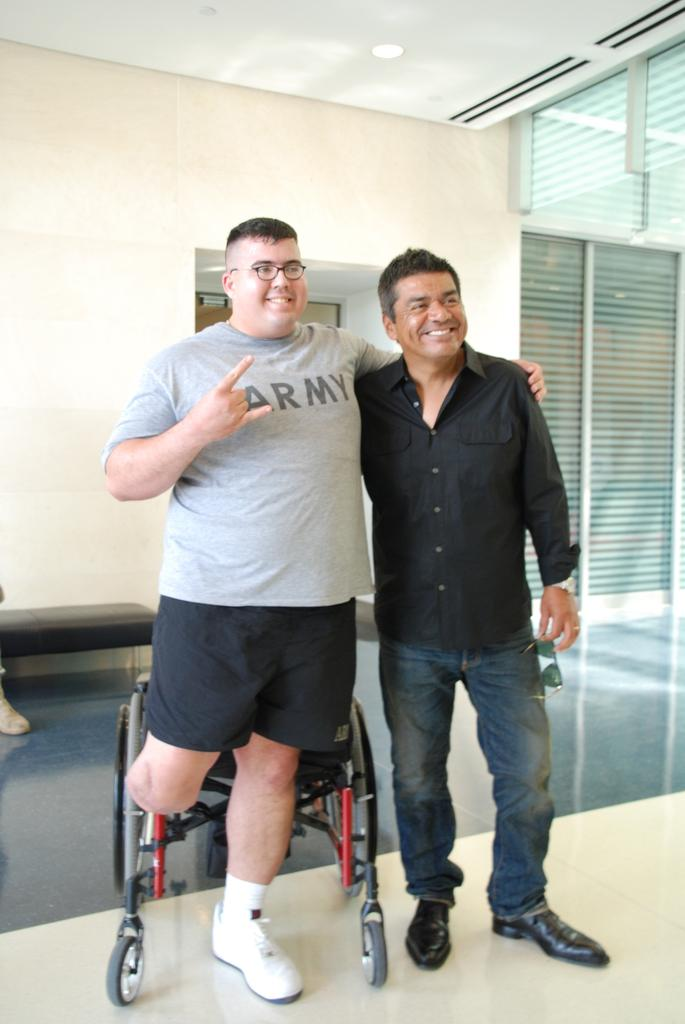How many people are present in the image? There are two persons standing in the image. What is located behind one of the persons? There is a wheelchair behind one of the persons. What can be seen in the background of the image? There is a wall in the background of the image. What feature is present on the wall? There is a door on the wall. What type of furniture is visible in the image? There is a sofa in the image. What type of ring can be seen on the person's finger in the image? There is no ring visible on any person's finger in the image. Can you tell me how much sugar is on the sofa in the image? There is no sugar present on the sofa in the image. 